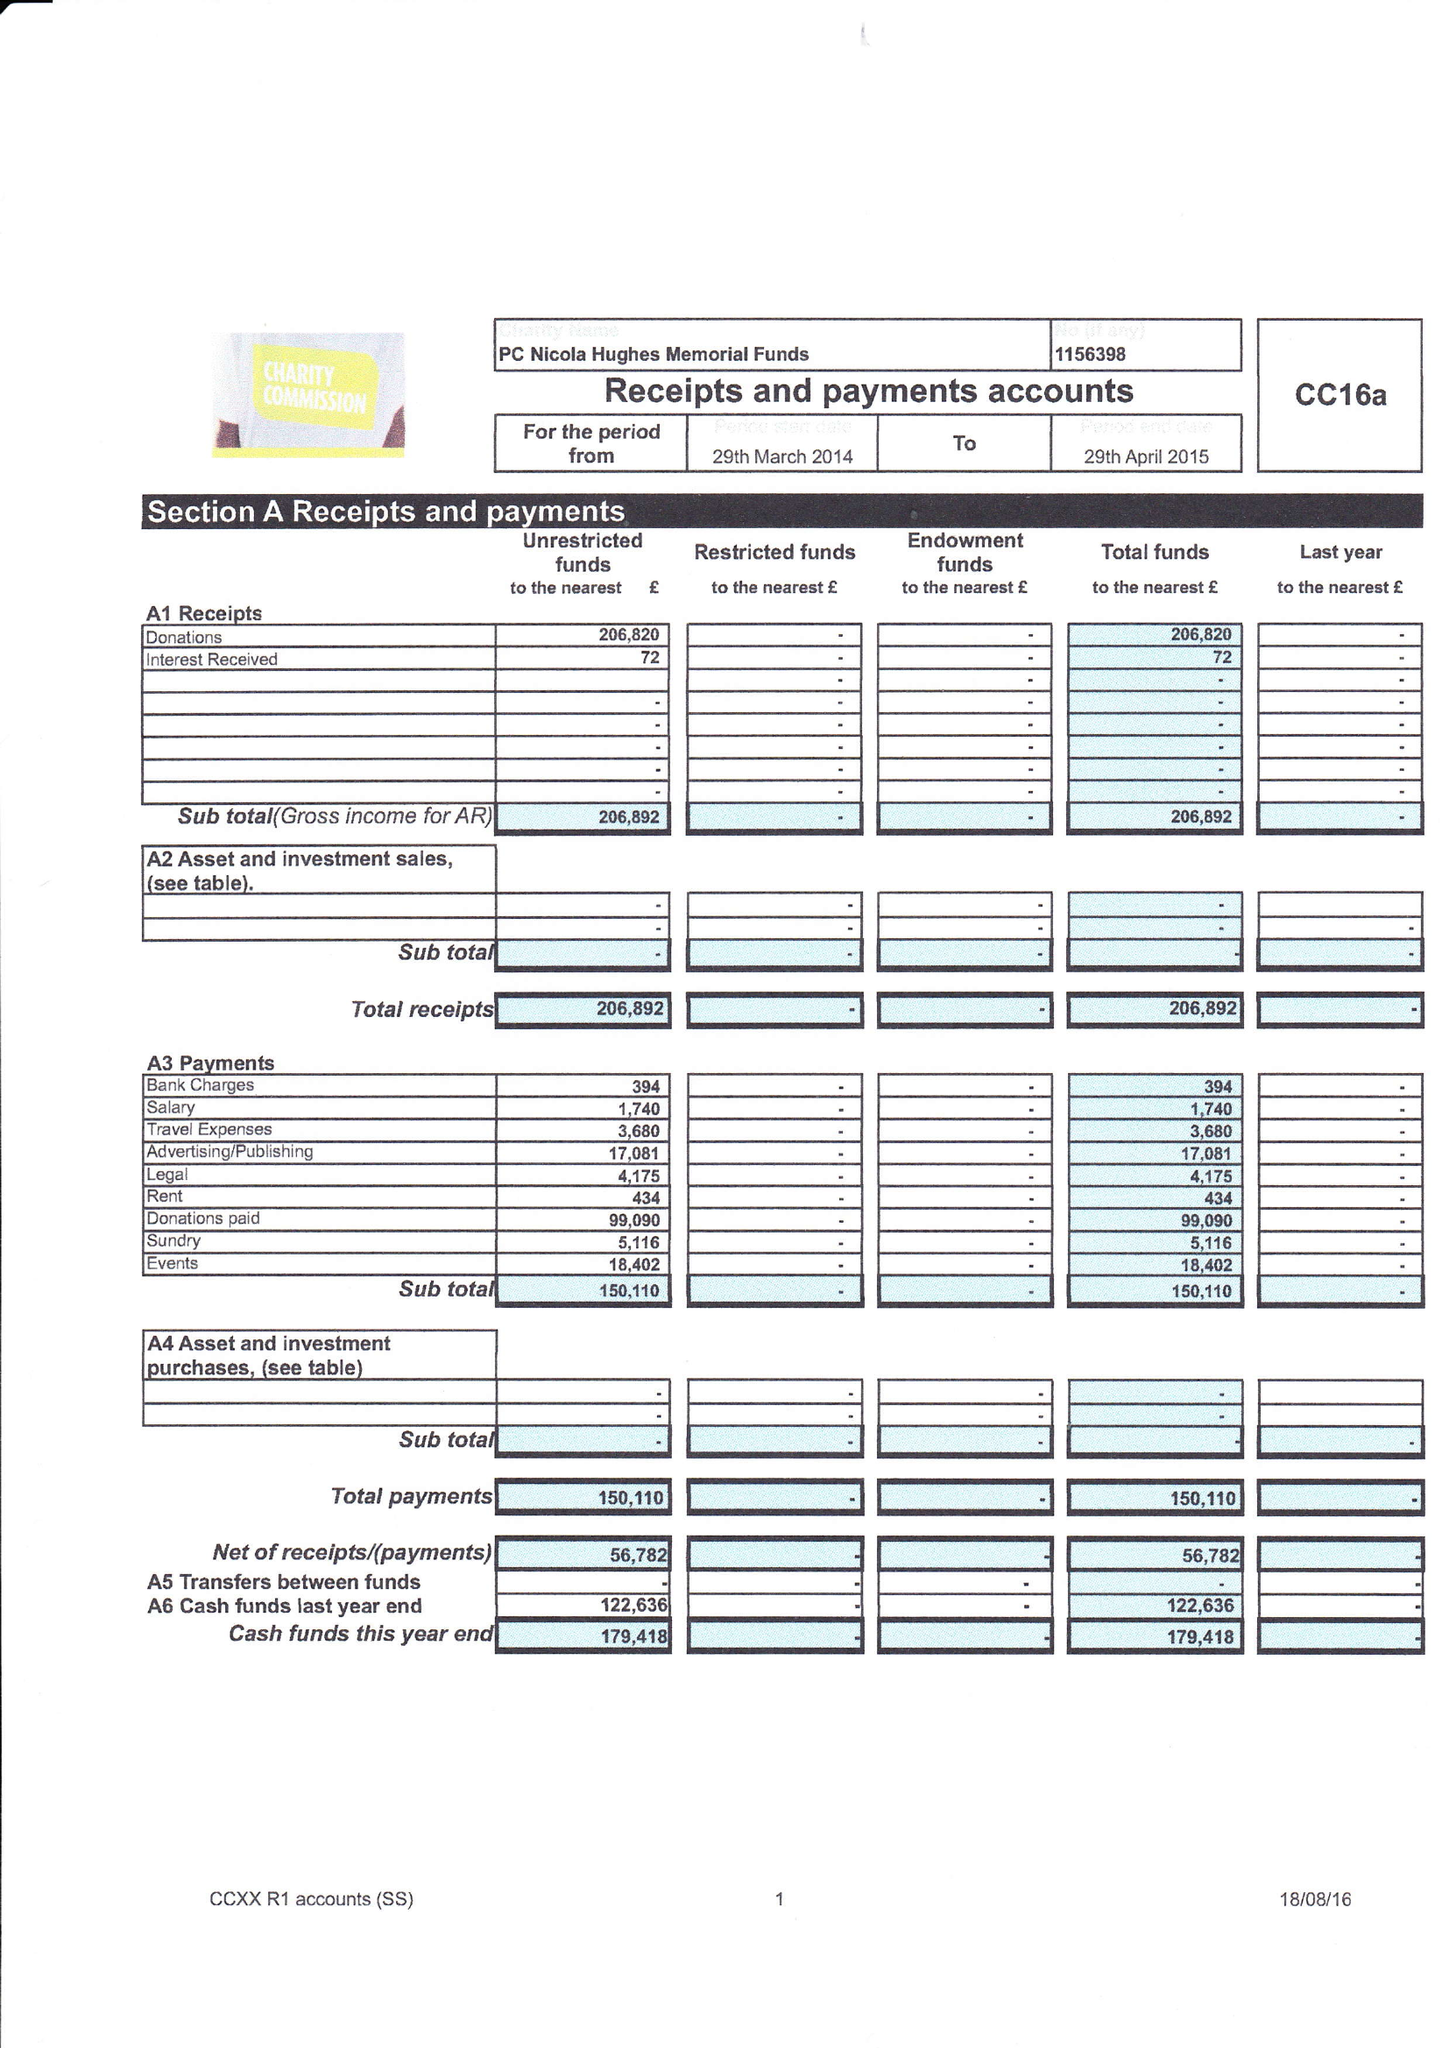What is the value for the address__post_town?
Answer the question using a single word or phrase. OLDHAM 